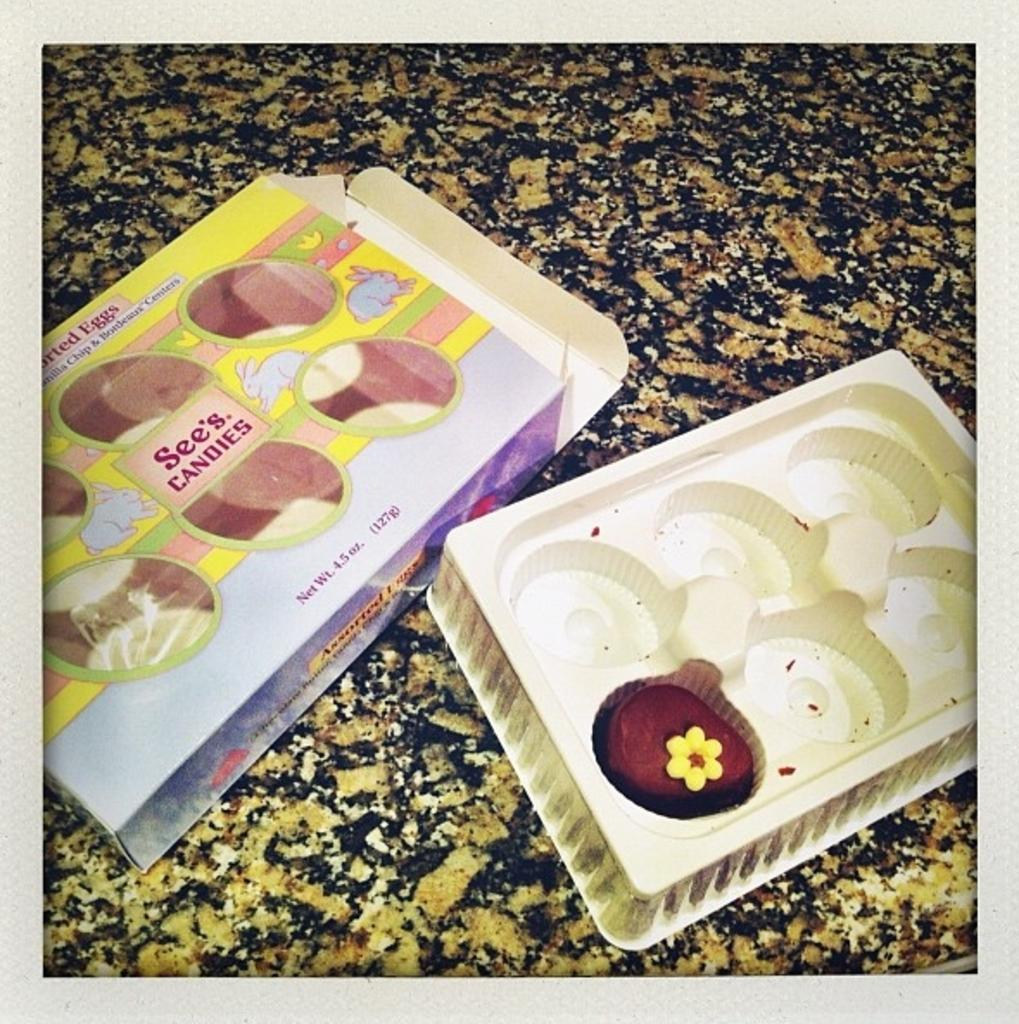What is the main object in the image? There is a box in the image. What else can be seen in the image besides the box? There is a tray with food in the image. Where are the box and tray placed? The box and tray are placed on a stone slab. What is depicted on the box? The box has images of animals on it and there is text on the box. What type of error can be seen on the monkey's face in the image? There is no monkey present in the image, and therefore no error can be seen on its face. 